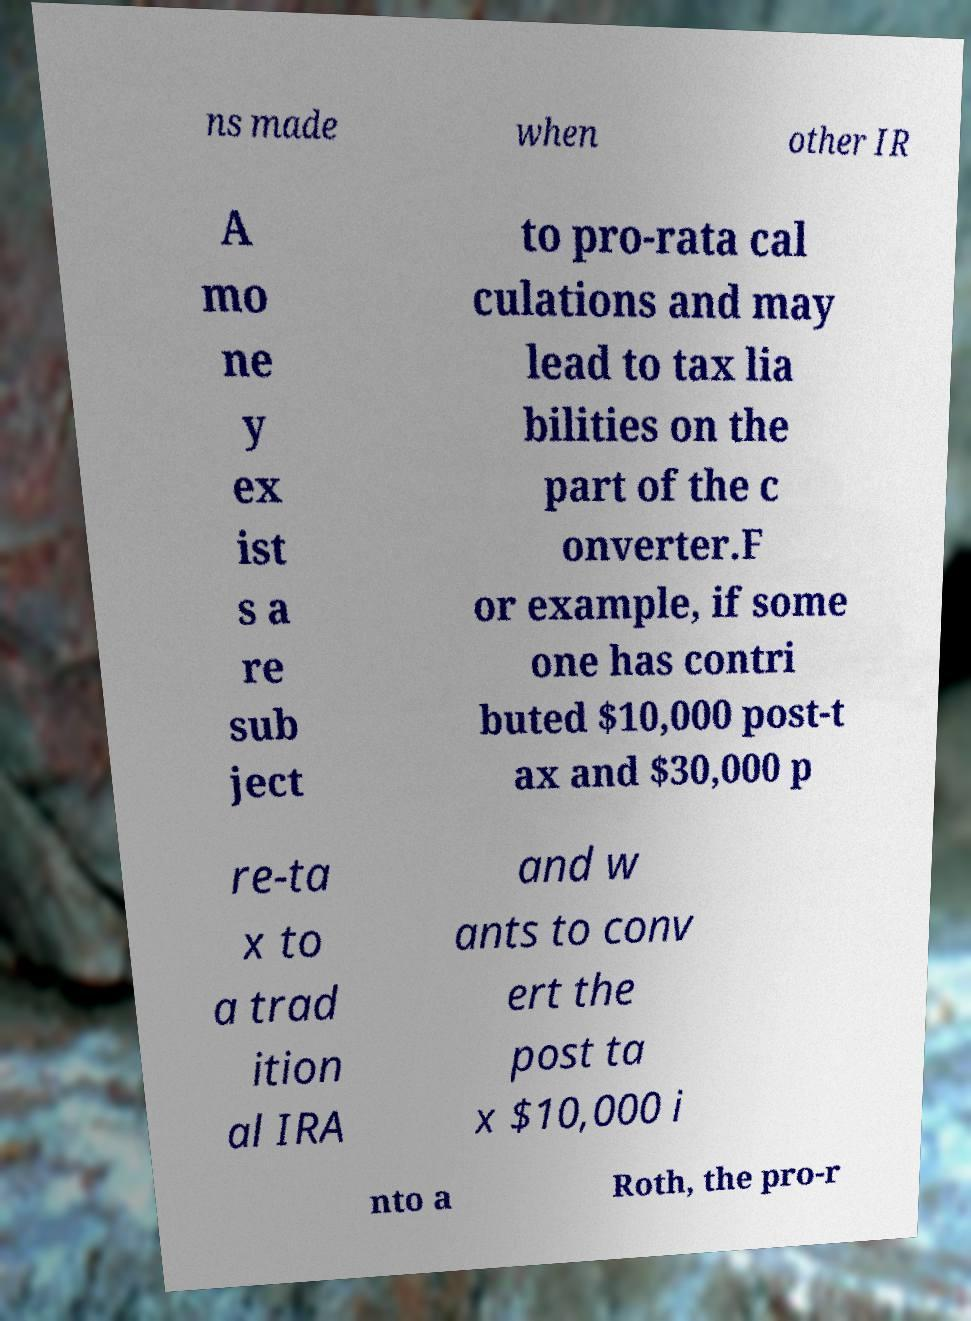Please identify and transcribe the text found in this image. ns made when other IR A mo ne y ex ist s a re sub ject to pro-rata cal culations and may lead to tax lia bilities on the part of the c onverter.F or example, if some one has contri buted $10,000 post-t ax and $30,000 p re-ta x to a trad ition al IRA and w ants to conv ert the post ta x $10,000 i nto a Roth, the pro-r 